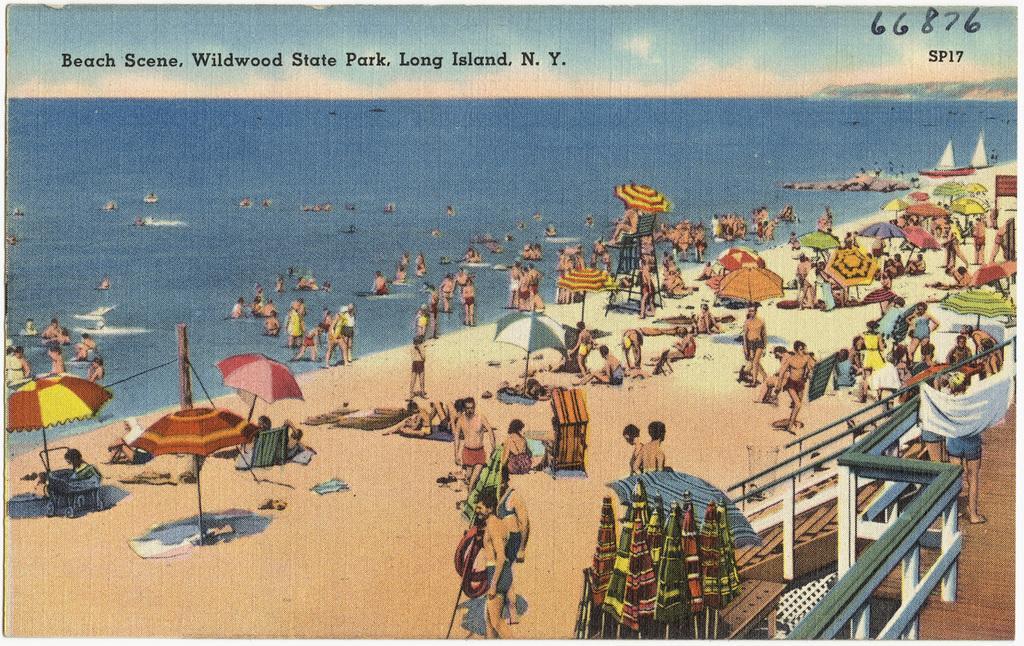How would you summarize this image in a sentence or two? In this image, we can see depiction of people and umbrellas on the beach. There is a staircase in the bottom right of the image. There is a text at the top of the image. There are boats in the top right of the image. 